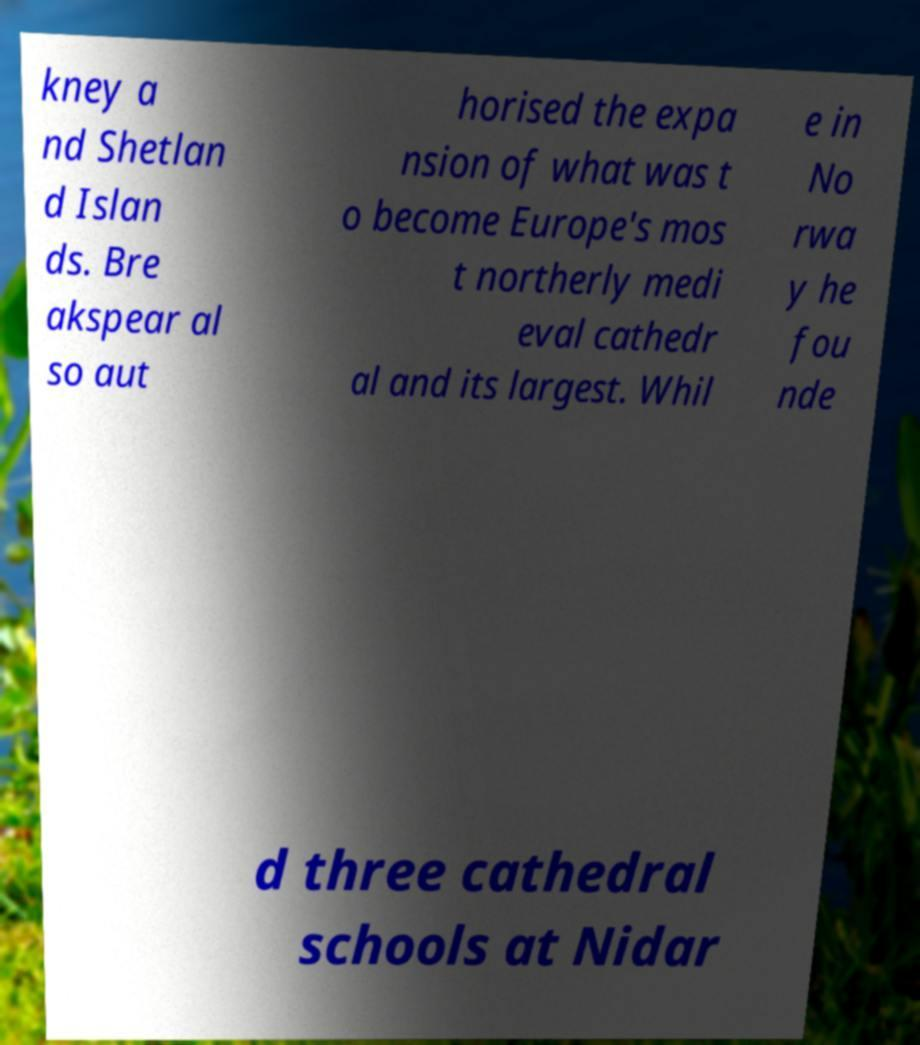Could you assist in decoding the text presented in this image and type it out clearly? kney a nd Shetlan d Islan ds. Bre akspear al so aut horised the expa nsion of what was t o become Europe's mos t northerly medi eval cathedr al and its largest. Whil e in No rwa y he fou nde d three cathedral schools at Nidar 